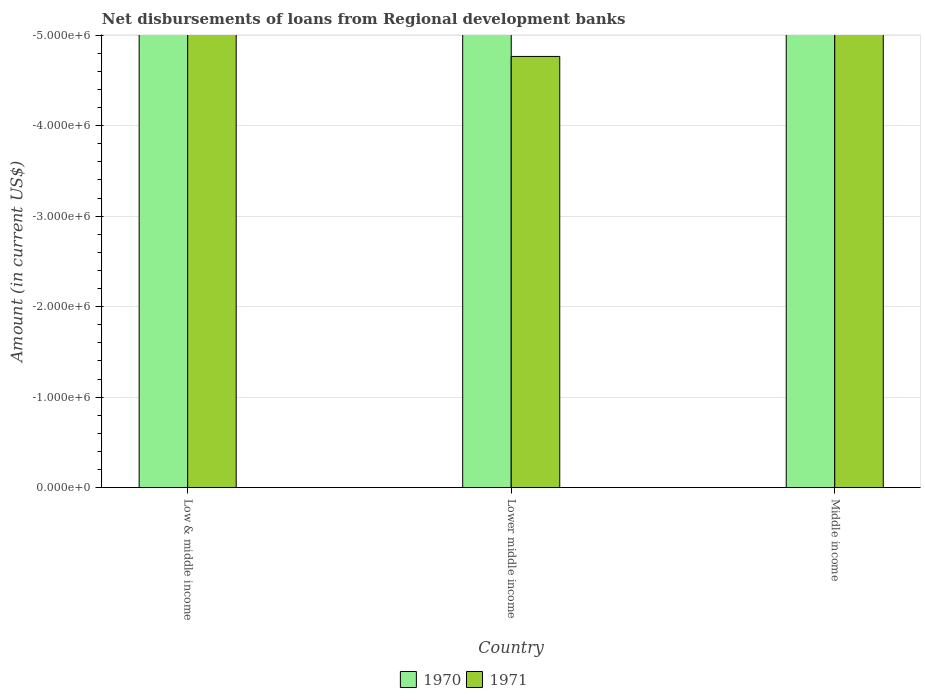How many different coloured bars are there?
Keep it short and to the point. 0. What is the label of the 2nd group of bars from the left?
Keep it short and to the point. Lower middle income. What is the amount of disbursements of loans from regional development banks in 1971 in Middle income?
Your response must be concise. 0. What is the difference between the amount of disbursements of loans from regional development banks in 1970 in Middle income and the amount of disbursements of loans from regional development banks in 1971 in Low & middle income?
Your answer should be very brief. 0. In how many countries, is the amount of disbursements of loans from regional development banks in 1971 greater than -1600000 US$?
Give a very brief answer. 0. In how many countries, is the amount of disbursements of loans from regional development banks in 1970 greater than the average amount of disbursements of loans from regional development banks in 1970 taken over all countries?
Ensure brevity in your answer.  0. How many bars are there?
Your response must be concise. 0. Does the graph contain any zero values?
Offer a very short reply. Yes. Does the graph contain grids?
Make the answer very short. Yes. Where does the legend appear in the graph?
Your answer should be compact. Bottom center. How many legend labels are there?
Offer a terse response. 2. What is the title of the graph?
Give a very brief answer. Net disbursements of loans from Regional development banks. Does "1997" appear as one of the legend labels in the graph?
Provide a succinct answer. No. What is the label or title of the X-axis?
Keep it short and to the point. Country. What is the Amount (in current US$) in 1970 in Low & middle income?
Offer a terse response. 0. What is the Amount (in current US$) in 1971 in Low & middle income?
Offer a terse response. 0. What is the Amount (in current US$) in 1970 in Lower middle income?
Offer a terse response. 0. What is the Amount (in current US$) in 1971 in Lower middle income?
Keep it short and to the point. 0. What is the Amount (in current US$) in 1970 in Middle income?
Offer a very short reply. 0. What is the total Amount (in current US$) of 1970 in the graph?
Your answer should be very brief. 0. What is the average Amount (in current US$) of 1970 per country?
Give a very brief answer. 0. What is the average Amount (in current US$) of 1971 per country?
Offer a terse response. 0. 